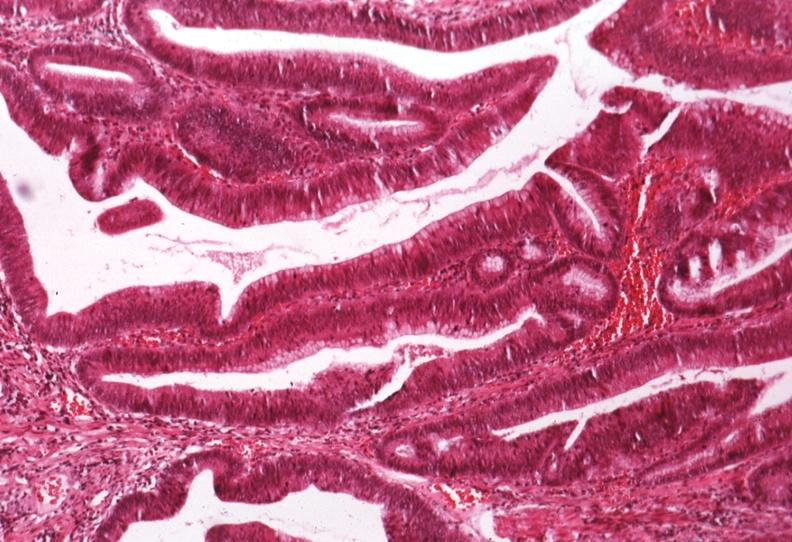s hemochromatosis present?
Answer the question using a single word or phrase. No 